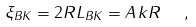Convert formula to latex. <formula><loc_0><loc_0><loc_500><loc_500>\xi _ { B K } = 2 R L _ { B K } = A \, k R \ \ ,</formula> 